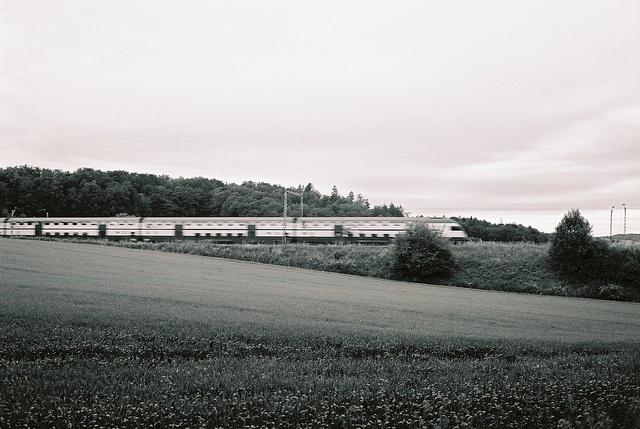Describe the objects in this image and their specific colors. I can see a train in white, lightgray, darkgray, gray, and black tones in this image. 